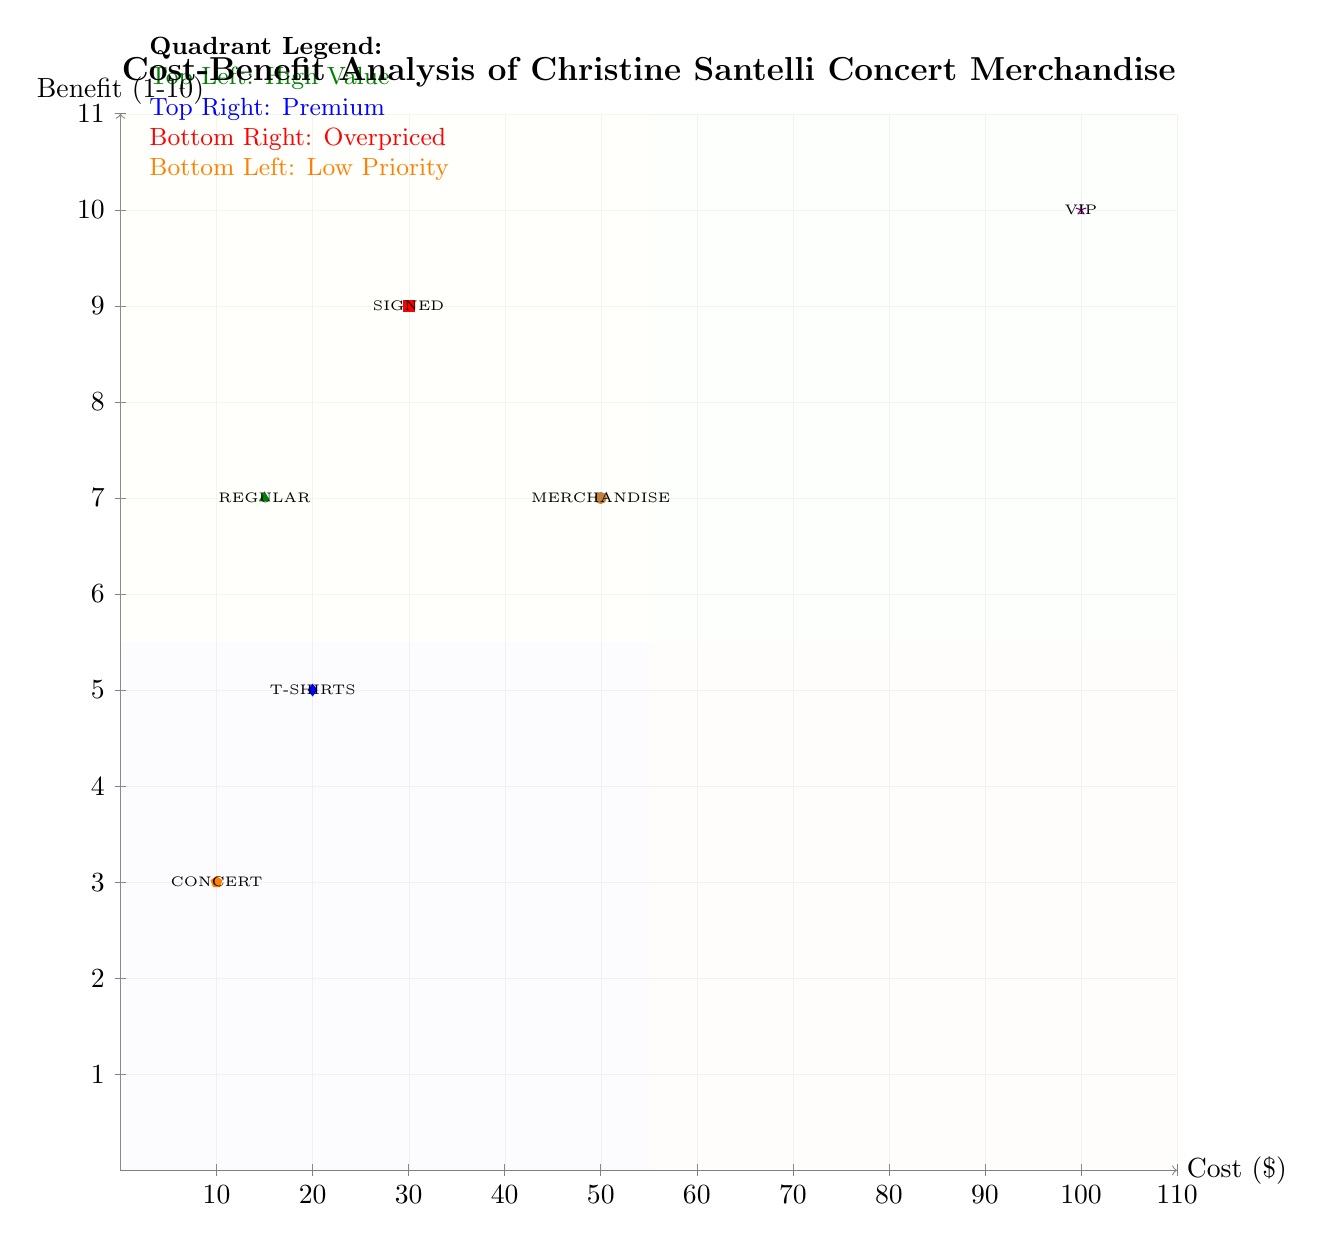What is the cost of VIP Passes? The diagram shows the cost axis, where the VIP Passes marker is located at a cost of 100.
Answer: 100 How many total merchandise items are represented in the diagram? The diagram features 6 different merchandise items: T-Shirts, Signed Albums, Regular Albums, Concert Posters, VIP Passes, and Merchandise Bundles.
Answer: 6 What is the benefit rating of Signed Albums? The diagram displays the benefit for Signed Albums, which is marked at a level of 9 on the benefit axis.
Answer: 9 Which merchandise item has the lowest benefit-to-cost ratio? To determine this, we need to calculate the benefit-to-cost ratio for each item. Concert Posters have a ratio of 0.3 (3/10), which is the lowest compared to others.
Answer: Concert Posters Which item is categorized in the top left quadrant? The top left quadrant is marked for high-value items; the only item that falls in this category is Signed Albums, which offers high emotional value relative to its cost.
Answer: Signed Albums What is the cost of Merchandise Bundles? According to the diagram, the cost indicated for Merchandise Bundles is 50.
Answer: 50 How does the benefit of Regular Albums compare to T-Shirts? Regular Albums have a benefit of 7, while T-Shirts have a lower benefit of 5, meaning Regular Albums provide more value relative to T-Shirts.
Answer: Regular Albums Which quadrant contains items classified as overpriced? The bottom right quadrant is designated for overpriced items; it includes items with relatively high costs and lower benefits.
Answer: Bottom Right What significant feature is marked in the quadrant legend for the top left section? The quadrant legend specifies that the top left section is labeled as "High Value", indicating that items here provide significant benefits for their cost.
Answer: High Value 